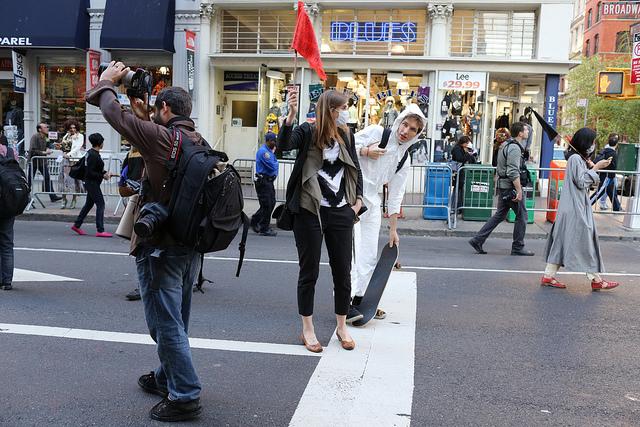What color is the line on the road?
Answer briefly. White. Are these protesters?
Write a very short answer. Yes. What kind of store is in the background?
Be succinct. Clothing. Are these American flags?
Answer briefly. No. 